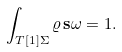<formula> <loc_0><loc_0><loc_500><loc_500>\int _ { T [ 1 ] \Sigma } \varrho \, \mathbf s { \omega } = 1 .</formula> 